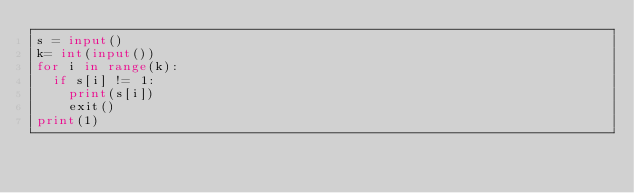<code> <loc_0><loc_0><loc_500><loc_500><_Python_>s = input()
k= int(input())
for i in range(k):
  if s[i] != 1:
    print(s[i])
    exit()
print(1)</code> 